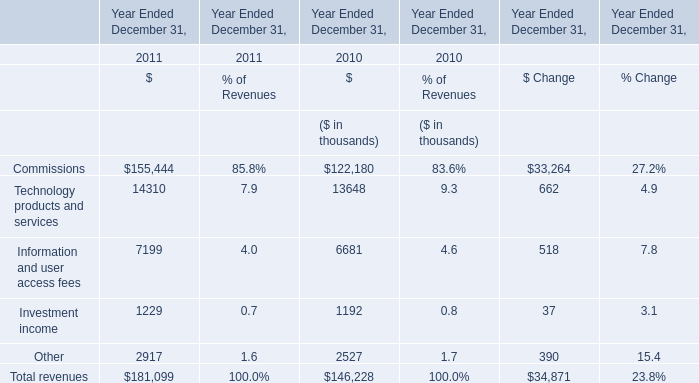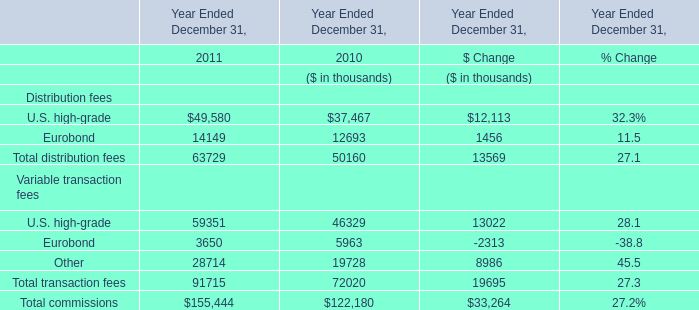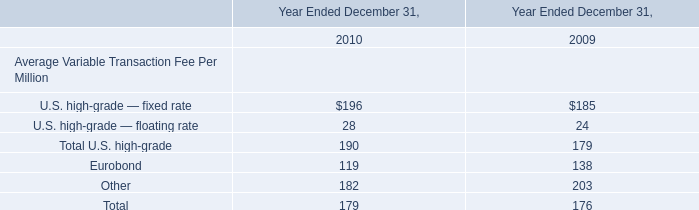In the year with the most U.S. high-grade, what is the growth rate of Eurobond? 
Computations: ((14149 - 12693) / 14149)
Answer: 0.1029. 